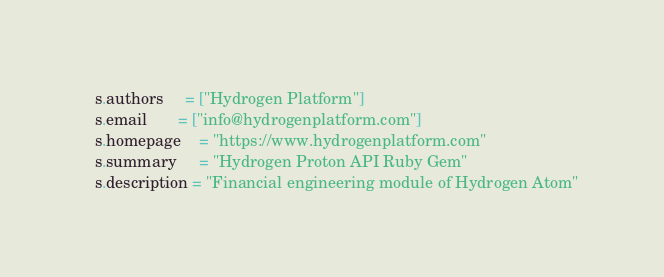<code> <loc_0><loc_0><loc_500><loc_500><_Ruby_>  s.authors     = ["Hydrogen Platform"]
  s.email       = ["info@hydrogenplatform.com"]
  s.homepage    = "https://www.hydrogenplatform.com"
  s.summary     = "Hydrogen Proton API Ruby Gem"
  s.description = "Financial engineering module of Hydrogen Atom"</code> 